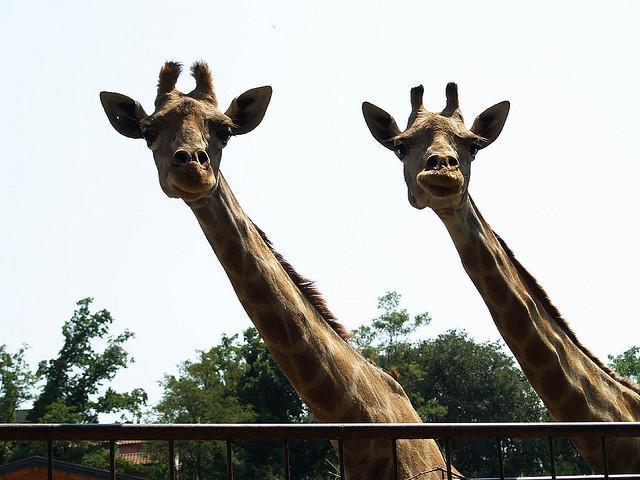How many animals?
Give a very brief answer. 2. How many animals are in the photo?
Give a very brief answer. 2. How many giraffes can you see?
Give a very brief answer. 2. How many people are walking under the umbrella?
Give a very brief answer. 0. 